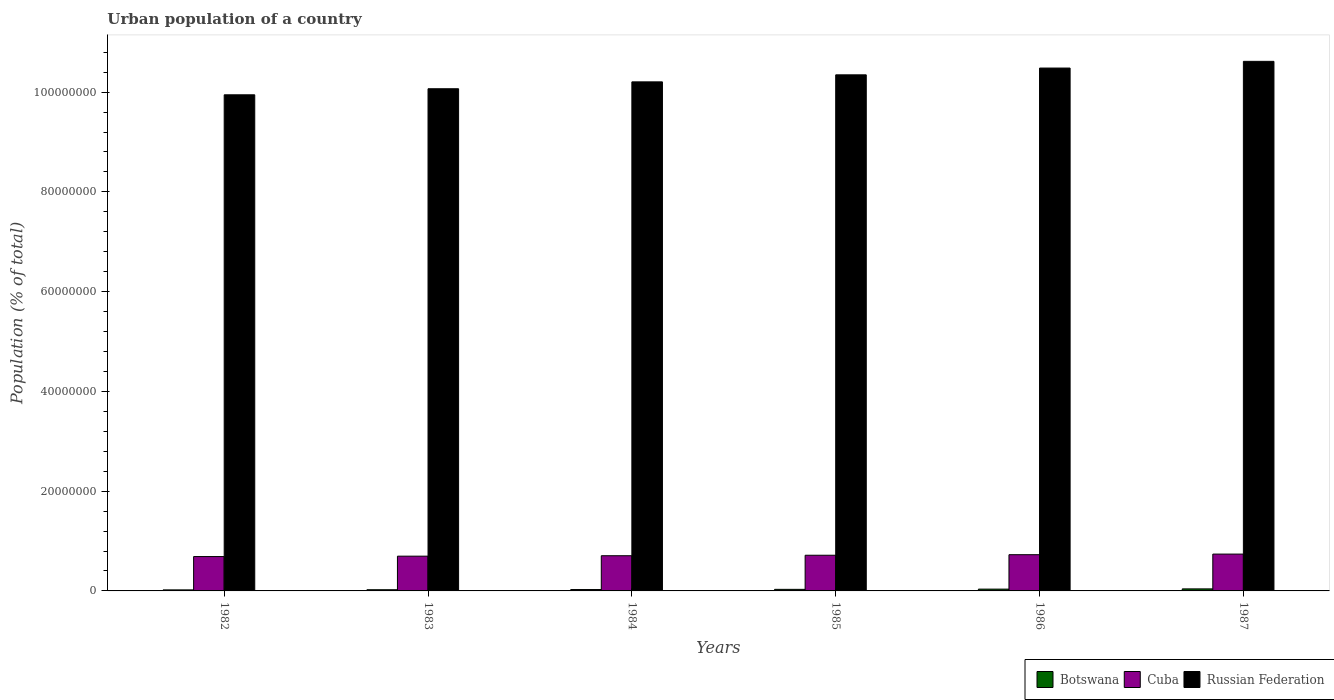How many different coloured bars are there?
Provide a short and direct response. 3. How many groups of bars are there?
Your answer should be very brief. 6. Are the number of bars on each tick of the X-axis equal?
Your answer should be compact. Yes. How many bars are there on the 6th tick from the left?
Your answer should be very brief. 3. What is the label of the 5th group of bars from the left?
Keep it short and to the point. 1986. In how many cases, is the number of bars for a given year not equal to the number of legend labels?
Keep it short and to the point. 0. What is the urban population in Russian Federation in 1983?
Provide a succinct answer. 1.01e+08. Across all years, what is the maximum urban population in Russian Federation?
Your answer should be compact. 1.06e+08. Across all years, what is the minimum urban population in Russian Federation?
Give a very brief answer. 9.95e+07. What is the total urban population in Russian Federation in the graph?
Give a very brief answer. 6.17e+08. What is the difference between the urban population in Russian Federation in 1982 and that in 1985?
Keep it short and to the point. -4.00e+06. What is the difference between the urban population in Russian Federation in 1982 and the urban population in Botswana in 1983?
Your answer should be compact. 9.92e+07. What is the average urban population in Russian Federation per year?
Ensure brevity in your answer.  1.03e+08. In the year 1983, what is the difference between the urban population in Botswana and urban population in Cuba?
Keep it short and to the point. -6.73e+06. In how many years, is the urban population in Russian Federation greater than 104000000 %?
Keep it short and to the point. 2. What is the ratio of the urban population in Cuba in 1982 to that in 1984?
Keep it short and to the point. 0.98. Is the difference between the urban population in Botswana in 1983 and 1987 greater than the difference between the urban population in Cuba in 1983 and 1987?
Your answer should be very brief. Yes. What is the difference between the highest and the second highest urban population in Cuba?
Provide a short and direct response. 1.23e+05. What is the difference between the highest and the lowest urban population in Cuba?
Keep it short and to the point. 4.96e+05. What does the 1st bar from the left in 1982 represents?
Keep it short and to the point. Botswana. What does the 1st bar from the right in 1987 represents?
Give a very brief answer. Russian Federation. What is the difference between two consecutive major ticks on the Y-axis?
Your answer should be compact. 2.00e+07. Does the graph contain any zero values?
Ensure brevity in your answer.  No. Does the graph contain grids?
Your answer should be compact. No. How are the legend labels stacked?
Keep it short and to the point. Horizontal. What is the title of the graph?
Your response must be concise. Urban population of a country. What is the label or title of the X-axis?
Provide a short and direct response. Years. What is the label or title of the Y-axis?
Offer a very short reply. Population (% of total). What is the Population (% of total) in Botswana in 1982?
Offer a very short reply. 2.09e+05. What is the Population (% of total) of Cuba in 1982?
Your answer should be compact. 6.89e+06. What is the Population (% of total) in Russian Federation in 1982?
Provide a short and direct response. 9.95e+07. What is the Population (% of total) of Botswana in 1983?
Keep it short and to the point. 2.40e+05. What is the Population (% of total) of Cuba in 1983?
Make the answer very short. 6.97e+06. What is the Population (% of total) in Russian Federation in 1983?
Provide a short and direct response. 1.01e+08. What is the Population (% of total) of Botswana in 1984?
Provide a short and direct response. 2.76e+05. What is the Population (% of total) of Cuba in 1984?
Provide a short and direct response. 7.06e+06. What is the Population (% of total) of Russian Federation in 1984?
Make the answer very short. 1.02e+08. What is the Population (% of total) of Botswana in 1985?
Your response must be concise. 3.16e+05. What is the Population (% of total) of Cuba in 1985?
Your response must be concise. 7.15e+06. What is the Population (% of total) in Russian Federation in 1985?
Ensure brevity in your answer.  1.03e+08. What is the Population (% of total) of Botswana in 1986?
Your response must be concise. 3.60e+05. What is the Population (% of total) of Cuba in 1986?
Make the answer very short. 7.26e+06. What is the Population (% of total) in Russian Federation in 1986?
Your response must be concise. 1.05e+08. What is the Population (% of total) in Botswana in 1987?
Offer a very short reply. 4.08e+05. What is the Population (% of total) of Cuba in 1987?
Your response must be concise. 7.39e+06. What is the Population (% of total) of Russian Federation in 1987?
Provide a succinct answer. 1.06e+08. Across all years, what is the maximum Population (% of total) in Botswana?
Keep it short and to the point. 4.08e+05. Across all years, what is the maximum Population (% of total) of Cuba?
Ensure brevity in your answer.  7.39e+06. Across all years, what is the maximum Population (% of total) of Russian Federation?
Provide a succinct answer. 1.06e+08. Across all years, what is the minimum Population (% of total) in Botswana?
Your response must be concise. 2.09e+05. Across all years, what is the minimum Population (% of total) in Cuba?
Your answer should be very brief. 6.89e+06. Across all years, what is the minimum Population (% of total) of Russian Federation?
Your answer should be compact. 9.95e+07. What is the total Population (% of total) of Botswana in the graph?
Your answer should be compact. 1.81e+06. What is the total Population (% of total) of Cuba in the graph?
Offer a terse response. 4.27e+07. What is the total Population (% of total) of Russian Federation in the graph?
Provide a succinct answer. 6.17e+08. What is the difference between the Population (% of total) in Botswana in 1982 and that in 1983?
Provide a succinct answer. -3.20e+04. What is the difference between the Population (% of total) in Cuba in 1982 and that in 1983?
Offer a terse response. -7.95e+04. What is the difference between the Population (% of total) of Russian Federation in 1982 and that in 1983?
Your answer should be very brief. -1.21e+06. What is the difference between the Population (% of total) in Botswana in 1982 and that in 1984?
Your answer should be very brief. -6.78e+04. What is the difference between the Population (% of total) of Cuba in 1982 and that in 1984?
Provide a short and direct response. -1.66e+05. What is the difference between the Population (% of total) of Russian Federation in 1982 and that in 1984?
Your response must be concise. -2.59e+06. What is the difference between the Population (% of total) in Botswana in 1982 and that in 1985?
Provide a succinct answer. -1.08e+05. What is the difference between the Population (% of total) in Cuba in 1982 and that in 1985?
Give a very brief answer. -2.62e+05. What is the difference between the Population (% of total) of Russian Federation in 1982 and that in 1985?
Provide a short and direct response. -4.00e+06. What is the difference between the Population (% of total) in Botswana in 1982 and that in 1986?
Provide a short and direct response. -1.52e+05. What is the difference between the Population (% of total) of Cuba in 1982 and that in 1986?
Your answer should be very brief. -3.73e+05. What is the difference between the Population (% of total) of Russian Federation in 1982 and that in 1986?
Offer a terse response. -5.36e+06. What is the difference between the Population (% of total) in Botswana in 1982 and that in 1987?
Make the answer very short. -2.00e+05. What is the difference between the Population (% of total) in Cuba in 1982 and that in 1987?
Offer a very short reply. -4.96e+05. What is the difference between the Population (% of total) of Russian Federation in 1982 and that in 1987?
Give a very brief answer. -6.71e+06. What is the difference between the Population (% of total) in Botswana in 1983 and that in 1984?
Your answer should be very brief. -3.58e+04. What is the difference between the Population (% of total) of Cuba in 1983 and that in 1984?
Ensure brevity in your answer.  -8.61e+04. What is the difference between the Population (% of total) of Russian Federation in 1983 and that in 1984?
Provide a succinct answer. -1.38e+06. What is the difference between the Population (% of total) in Botswana in 1983 and that in 1985?
Make the answer very short. -7.56e+04. What is the difference between the Population (% of total) in Cuba in 1983 and that in 1985?
Keep it short and to the point. -1.83e+05. What is the difference between the Population (% of total) in Russian Federation in 1983 and that in 1985?
Offer a very short reply. -2.79e+06. What is the difference between the Population (% of total) in Botswana in 1983 and that in 1986?
Provide a succinct answer. -1.20e+05. What is the difference between the Population (% of total) in Cuba in 1983 and that in 1986?
Your answer should be compact. -2.94e+05. What is the difference between the Population (% of total) of Russian Federation in 1983 and that in 1986?
Provide a short and direct response. -4.15e+06. What is the difference between the Population (% of total) of Botswana in 1983 and that in 1987?
Give a very brief answer. -1.68e+05. What is the difference between the Population (% of total) in Cuba in 1983 and that in 1987?
Keep it short and to the point. -4.17e+05. What is the difference between the Population (% of total) in Russian Federation in 1983 and that in 1987?
Provide a short and direct response. -5.49e+06. What is the difference between the Population (% of total) of Botswana in 1984 and that in 1985?
Ensure brevity in your answer.  -3.98e+04. What is the difference between the Population (% of total) of Cuba in 1984 and that in 1985?
Give a very brief answer. -9.68e+04. What is the difference between the Population (% of total) of Russian Federation in 1984 and that in 1985?
Keep it short and to the point. -1.41e+06. What is the difference between the Population (% of total) in Botswana in 1984 and that in 1986?
Make the answer very short. -8.39e+04. What is the difference between the Population (% of total) in Cuba in 1984 and that in 1986?
Give a very brief answer. -2.08e+05. What is the difference between the Population (% of total) of Russian Federation in 1984 and that in 1986?
Offer a terse response. -2.77e+06. What is the difference between the Population (% of total) in Botswana in 1984 and that in 1987?
Provide a short and direct response. -1.32e+05. What is the difference between the Population (% of total) of Cuba in 1984 and that in 1987?
Your response must be concise. -3.30e+05. What is the difference between the Population (% of total) of Russian Federation in 1984 and that in 1987?
Give a very brief answer. -4.11e+06. What is the difference between the Population (% of total) of Botswana in 1985 and that in 1986?
Your answer should be very brief. -4.41e+04. What is the difference between the Population (% of total) in Cuba in 1985 and that in 1986?
Your answer should be very brief. -1.11e+05. What is the difference between the Population (% of total) in Russian Federation in 1985 and that in 1986?
Offer a very short reply. -1.36e+06. What is the difference between the Population (% of total) of Botswana in 1985 and that in 1987?
Your answer should be compact. -9.24e+04. What is the difference between the Population (% of total) in Cuba in 1985 and that in 1987?
Keep it short and to the point. -2.34e+05. What is the difference between the Population (% of total) in Russian Federation in 1985 and that in 1987?
Offer a very short reply. -2.70e+06. What is the difference between the Population (% of total) of Botswana in 1986 and that in 1987?
Offer a very short reply. -4.83e+04. What is the difference between the Population (% of total) in Cuba in 1986 and that in 1987?
Your answer should be compact. -1.23e+05. What is the difference between the Population (% of total) of Russian Federation in 1986 and that in 1987?
Offer a very short reply. -1.34e+06. What is the difference between the Population (% of total) in Botswana in 1982 and the Population (% of total) in Cuba in 1983?
Make the answer very short. -6.76e+06. What is the difference between the Population (% of total) in Botswana in 1982 and the Population (% of total) in Russian Federation in 1983?
Your answer should be compact. -1.00e+08. What is the difference between the Population (% of total) of Cuba in 1982 and the Population (% of total) of Russian Federation in 1983?
Ensure brevity in your answer.  -9.38e+07. What is the difference between the Population (% of total) of Botswana in 1982 and the Population (% of total) of Cuba in 1984?
Provide a short and direct response. -6.85e+06. What is the difference between the Population (% of total) of Botswana in 1982 and the Population (% of total) of Russian Federation in 1984?
Make the answer very short. -1.02e+08. What is the difference between the Population (% of total) in Cuba in 1982 and the Population (% of total) in Russian Federation in 1984?
Keep it short and to the point. -9.52e+07. What is the difference between the Population (% of total) of Botswana in 1982 and the Population (% of total) of Cuba in 1985?
Offer a very short reply. -6.94e+06. What is the difference between the Population (% of total) of Botswana in 1982 and the Population (% of total) of Russian Federation in 1985?
Make the answer very short. -1.03e+08. What is the difference between the Population (% of total) in Cuba in 1982 and the Population (% of total) in Russian Federation in 1985?
Your response must be concise. -9.66e+07. What is the difference between the Population (% of total) of Botswana in 1982 and the Population (% of total) of Cuba in 1986?
Your response must be concise. -7.05e+06. What is the difference between the Population (% of total) of Botswana in 1982 and the Population (% of total) of Russian Federation in 1986?
Give a very brief answer. -1.05e+08. What is the difference between the Population (% of total) in Cuba in 1982 and the Population (% of total) in Russian Federation in 1986?
Provide a short and direct response. -9.79e+07. What is the difference between the Population (% of total) of Botswana in 1982 and the Population (% of total) of Cuba in 1987?
Keep it short and to the point. -7.18e+06. What is the difference between the Population (% of total) in Botswana in 1982 and the Population (% of total) in Russian Federation in 1987?
Keep it short and to the point. -1.06e+08. What is the difference between the Population (% of total) in Cuba in 1982 and the Population (% of total) in Russian Federation in 1987?
Make the answer very short. -9.93e+07. What is the difference between the Population (% of total) in Botswana in 1983 and the Population (% of total) in Cuba in 1984?
Offer a very short reply. -6.81e+06. What is the difference between the Population (% of total) in Botswana in 1983 and the Population (% of total) in Russian Federation in 1984?
Your answer should be compact. -1.02e+08. What is the difference between the Population (% of total) in Cuba in 1983 and the Population (% of total) in Russian Federation in 1984?
Give a very brief answer. -9.51e+07. What is the difference between the Population (% of total) in Botswana in 1983 and the Population (% of total) in Cuba in 1985?
Your answer should be compact. -6.91e+06. What is the difference between the Population (% of total) of Botswana in 1983 and the Population (% of total) of Russian Federation in 1985?
Provide a short and direct response. -1.03e+08. What is the difference between the Population (% of total) in Cuba in 1983 and the Population (% of total) in Russian Federation in 1985?
Your response must be concise. -9.65e+07. What is the difference between the Population (% of total) of Botswana in 1983 and the Population (% of total) of Cuba in 1986?
Keep it short and to the point. -7.02e+06. What is the difference between the Population (% of total) of Botswana in 1983 and the Population (% of total) of Russian Federation in 1986?
Give a very brief answer. -1.05e+08. What is the difference between the Population (% of total) in Cuba in 1983 and the Population (% of total) in Russian Federation in 1986?
Provide a succinct answer. -9.79e+07. What is the difference between the Population (% of total) of Botswana in 1983 and the Population (% of total) of Cuba in 1987?
Offer a terse response. -7.15e+06. What is the difference between the Population (% of total) of Botswana in 1983 and the Population (% of total) of Russian Federation in 1987?
Offer a very short reply. -1.06e+08. What is the difference between the Population (% of total) of Cuba in 1983 and the Population (% of total) of Russian Federation in 1987?
Provide a short and direct response. -9.92e+07. What is the difference between the Population (% of total) of Botswana in 1984 and the Population (% of total) of Cuba in 1985?
Offer a very short reply. -6.88e+06. What is the difference between the Population (% of total) of Botswana in 1984 and the Population (% of total) of Russian Federation in 1985?
Your answer should be very brief. -1.03e+08. What is the difference between the Population (% of total) in Cuba in 1984 and the Population (% of total) in Russian Federation in 1985?
Offer a very short reply. -9.64e+07. What is the difference between the Population (% of total) in Botswana in 1984 and the Population (% of total) in Cuba in 1986?
Your answer should be very brief. -6.99e+06. What is the difference between the Population (% of total) in Botswana in 1984 and the Population (% of total) in Russian Federation in 1986?
Make the answer very short. -1.05e+08. What is the difference between the Population (% of total) of Cuba in 1984 and the Population (% of total) of Russian Federation in 1986?
Your answer should be compact. -9.78e+07. What is the difference between the Population (% of total) in Botswana in 1984 and the Population (% of total) in Cuba in 1987?
Give a very brief answer. -7.11e+06. What is the difference between the Population (% of total) of Botswana in 1984 and the Population (% of total) of Russian Federation in 1987?
Offer a terse response. -1.06e+08. What is the difference between the Population (% of total) of Cuba in 1984 and the Population (% of total) of Russian Federation in 1987?
Your answer should be very brief. -9.91e+07. What is the difference between the Population (% of total) of Botswana in 1985 and the Population (% of total) of Cuba in 1986?
Provide a succinct answer. -6.95e+06. What is the difference between the Population (% of total) of Botswana in 1985 and the Population (% of total) of Russian Federation in 1986?
Ensure brevity in your answer.  -1.05e+08. What is the difference between the Population (% of total) in Cuba in 1985 and the Population (% of total) in Russian Federation in 1986?
Provide a succinct answer. -9.77e+07. What is the difference between the Population (% of total) in Botswana in 1985 and the Population (% of total) in Cuba in 1987?
Give a very brief answer. -7.07e+06. What is the difference between the Population (% of total) in Botswana in 1985 and the Population (% of total) in Russian Federation in 1987?
Offer a very short reply. -1.06e+08. What is the difference between the Population (% of total) of Cuba in 1985 and the Population (% of total) of Russian Federation in 1987?
Give a very brief answer. -9.90e+07. What is the difference between the Population (% of total) of Botswana in 1986 and the Population (% of total) of Cuba in 1987?
Your answer should be very brief. -7.03e+06. What is the difference between the Population (% of total) in Botswana in 1986 and the Population (% of total) in Russian Federation in 1987?
Your answer should be compact. -1.06e+08. What is the difference between the Population (% of total) in Cuba in 1986 and the Population (% of total) in Russian Federation in 1987?
Ensure brevity in your answer.  -9.89e+07. What is the average Population (% of total) of Botswana per year?
Ensure brevity in your answer.  3.02e+05. What is the average Population (% of total) in Cuba per year?
Provide a short and direct response. 7.12e+06. What is the average Population (% of total) in Russian Federation per year?
Ensure brevity in your answer.  1.03e+08. In the year 1982, what is the difference between the Population (% of total) of Botswana and Population (% of total) of Cuba?
Provide a succinct answer. -6.68e+06. In the year 1982, what is the difference between the Population (% of total) of Botswana and Population (% of total) of Russian Federation?
Provide a short and direct response. -9.93e+07. In the year 1982, what is the difference between the Population (% of total) in Cuba and Population (% of total) in Russian Federation?
Keep it short and to the point. -9.26e+07. In the year 1983, what is the difference between the Population (% of total) in Botswana and Population (% of total) in Cuba?
Give a very brief answer. -6.73e+06. In the year 1983, what is the difference between the Population (% of total) of Botswana and Population (% of total) of Russian Federation?
Give a very brief answer. -1.00e+08. In the year 1983, what is the difference between the Population (% of total) in Cuba and Population (% of total) in Russian Federation?
Your answer should be very brief. -9.37e+07. In the year 1984, what is the difference between the Population (% of total) of Botswana and Population (% of total) of Cuba?
Your answer should be very brief. -6.78e+06. In the year 1984, what is the difference between the Population (% of total) in Botswana and Population (% of total) in Russian Federation?
Your answer should be compact. -1.02e+08. In the year 1984, what is the difference between the Population (% of total) in Cuba and Population (% of total) in Russian Federation?
Your answer should be compact. -9.50e+07. In the year 1985, what is the difference between the Population (% of total) in Botswana and Population (% of total) in Cuba?
Offer a very short reply. -6.84e+06. In the year 1985, what is the difference between the Population (% of total) of Botswana and Population (% of total) of Russian Federation?
Keep it short and to the point. -1.03e+08. In the year 1985, what is the difference between the Population (% of total) of Cuba and Population (% of total) of Russian Federation?
Make the answer very short. -9.63e+07. In the year 1986, what is the difference between the Population (% of total) of Botswana and Population (% of total) of Cuba?
Offer a very short reply. -6.90e+06. In the year 1986, what is the difference between the Population (% of total) in Botswana and Population (% of total) in Russian Federation?
Your response must be concise. -1.04e+08. In the year 1986, what is the difference between the Population (% of total) in Cuba and Population (% of total) in Russian Federation?
Your answer should be very brief. -9.76e+07. In the year 1987, what is the difference between the Population (% of total) in Botswana and Population (% of total) in Cuba?
Offer a terse response. -6.98e+06. In the year 1987, what is the difference between the Population (% of total) in Botswana and Population (% of total) in Russian Federation?
Give a very brief answer. -1.06e+08. In the year 1987, what is the difference between the Population (% of total) in Cuba and Population (% of total) in Russian Federation?
Offer a terse response. -9.88e+07. What is the ratio of the Population (% of total) of Botswana in 1982 to that in 1983?
Your response must be concise. 0.87. What is the ratio of the Population (% of total) of Cuba in 1982 to that in 1983?
Give a very brief answer. 0.99. What is the ratio of the Population (% of total) of Russian Federation in 1982 to that in 1983?
Provide a succinct answer. 0.99. What is the ratio of the Population (% of total) of Botswana in 1982 to that in 1984?
Offer a terse response. 0.75. What is the ratio of the Population (% of total) of Cuba in 1982 to that in 1984?
Keep it short and to the point. 0.98. What is the ratio of the Population (% of total) in Russian Federation in 1982 to that in 1984?
Provide a succinct answer. 0.97. What is the ratio of the Population (% of total) of Botswana in 1982 to that in 1985?
Give a very brief answer. 0.66. What is the ratio of the Population (% of total) of Cuba in 1982 to that in 1985?
Your answer should be very brief. 0.96. What is the ratio of the Population (% of total) of Russian Federation in 1982 to that in 1985?
Provide a short and direct response. 0.96. What is the ratio of the Population (% of total) in Botswana in 1982 to that in 1986?
Offer a terse response. 0.58. What is the ratio of the Population (% of total) in Cuba in 1982 to that in 1986?
Give a very brief answer. 0.95. What is the ratio of the Population (% of total) of Russian Federation in 1982 to that in 1986?
Keep it short and to the point. 0.95. What is the ratio of the Population (% of total) of Botswana in 1982 to that in 1987?
Ensure brevity in your answer.  0.51. What is the ratio of the Population (% of total) in Cuba in 1982 to that in 1987?
Offer a very short reply. 0.93. What is the ratio of the Population (% of total) of Russian Federation in 1982 to that in 1987?
Keep it short and to the point. 0.94. What is the ratio of the Population (% of total) in Botswana in 1983 to that in 1984?
Offer a terse response. 0.87. What is the ratio of the Population (% of total) of Cuba in 1983 to that in 1984?
Keep it short and to the point. 0.99. What is the ratio of the Population (% of total) in Russian Federation in 1983 to that in 1984?
Keep it short and to the point. 0.99. What is the ratio of the Population (% of total) of Botswana in 1983 to that in 1985?
Keep it short and to the point. 0.76. What is the ratio of the Population (% of total) in Cuba in 1983 to that in 1985?
Offer a very short reply. 0.97. What is the ratio of the Population (% of total) in Russian Federation in 1983 to that in 1985?
Give a very brief answer. 0.97. What is the ratio of the Population (% of total) of Botswana in 1983 to that in 1986?
Provide a succinct answer. 0.67. What is the ratio of the Population (% of total) in Cuba in 1983 to that in 1986?
Your response must be concise. 0.96. What is the ratio of the Population (% of total) in Russian Federation in 1983 to that in 1986?
Your answer should be compact. 0.96. What is the ratio of the Population (% of total) of Botswana in 1983 to that in 1987?
Provide a succinct answer. 0.59. What is the ratio of the Population (% of total) of Cuba in 1983 to that in 1987?
Your answer should be compact. 0.94. What is the ratio of the Population (% of total) of Russian Federation in 1983 to that in 1987?
Offer a very short reply. 0.95. What is the ratio of the Population (% of total) in Botswana in 1984 to that in 1985?
Make the answer very short. 0.87. What is the ratio of the Population (% of total) of Cuba in 1984 to that in 1985?
Your response must be concise. 0.99. What is the ratio of the Population (% of total) in Russian Federation in 1984 to that in 1985?
Give a very brief answer. 0.99. What is the ratio of the Population (% of total) in Botswana in 1984 to that in 1986?
Your answer should be compact. 0.77. What is the ratio of the Population (% of total) in Cuba in 1984 to that in 1986?
Provide a succinct answer. 0.97. What is the ratio of the Population (% of total) of Russian Federation in 1984 to that in 1986?
Provide a short and direct response. 0.97. What is the ratio of the Population (% of total) of Botswana in 1984 to that in 1987?
Your response must be concise. 0.68. What is the ratio of the Population (% of total) in Cuba in 1984 to that in 1987?
Ensure brevity in your answer.  0.96. What is the ratio of the Population (% of total) in Russian Federation in 1984 to that in 1987?
Offer a terse response. 0.96. What is the ratio of the Population (% of total) of Botswana in 1985 to that in 1986?
Make the answer very short. 0.88. What is the ratio of the Population (% of total) in Cuba in 1985 to that in 1986?
Make the answer very short. 0.98. What is the ratio of the Population (% of total) in Botswana in 1985 to that in 1987?
Give a very brief answer. 0.77. What is the ratio of the Population (% of total) in Cuba in 1985 to that in 1987?
Your answer should be compact. 0.97. What is the ratio of the Population (% of total) of Russian Federation in 1985 to that in 1987?
Ensure brevity in your answer.  0.97. What is the ratio of the Population (% of total) of Botswana in 1986 to that in 1987?
Provide a short and direct response. 0.88. What is the ratio of the Population (% of total) in Cuba in 1986 to that in 1987?
Offer a terse response. 0.98. What is the ratio of the Population (% of total) of Russian Federation in 1986 to that in 1987?
Your response must be concise. 0.99. What is the difference between the highest and the second highest Population (% of total) in Botswana?
Offer a terse response. 4.83e+04. What is the difference between the highest and the second highest Population (% of total) in Cuba?
Provide a short and direct response. 1.23e+05. What is the difference between the highest and the second highest Population (% of total) of Russian Federation?
Make the answer very short. 1.34e+06. What is the difference between the highest and the lowest Population (% of total) of Botswana?
Your answer should be compact. 2.00e+05. What is the difference between the highest and the lowest Population (% of total) of Cuba?
Provide a short and direct response. 4.96e+05. What is the difference between the highest and the lowest Population (% of total) in Russian Federation?
Your response must be concise. 6.71e+06. 